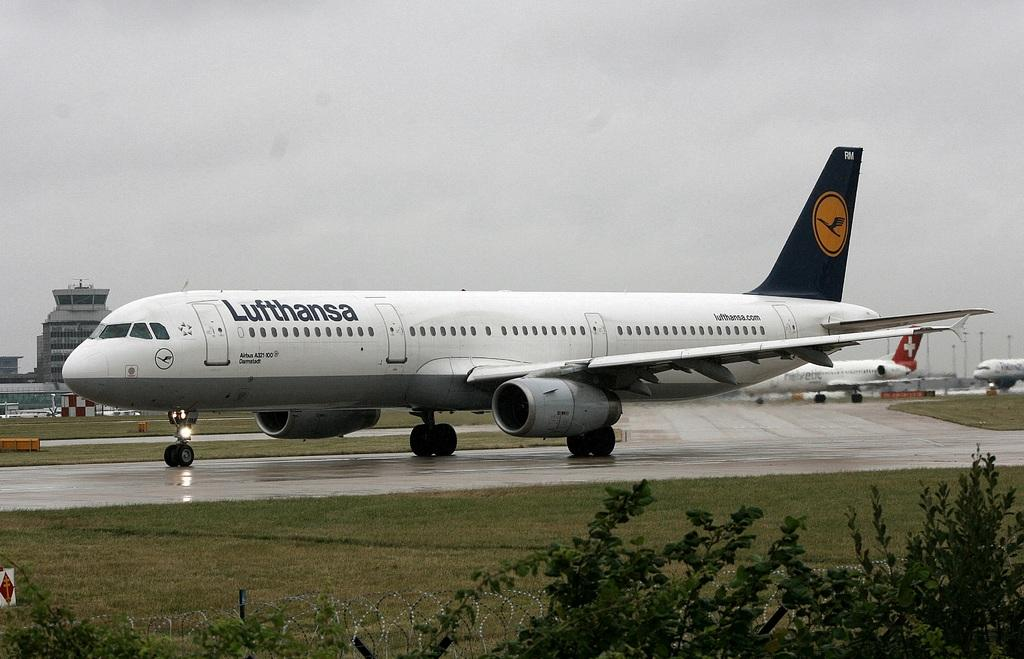What can be seen on the runway in the image? There are aeroplanes on the runway in the image. What type of barrier is present in the image? There is a fence in the image. What type of vegetation is visible in the image? There are trees in the image. What part of the ground can be seen in the image? The ground is visible in the image. What type of structures are present in the image? There are buildings in the image. What part of the natural environment is visible in the image? The sky is visible in the image, and clouds are present in the sky. Can you tell me how the aeroplanes are fighting each other in the image? There is no fighting between the aeroplanes in the image; they are simply parked on the runway. What type of comparison can be made between the trees and the buildings in the image? There is no comparison being made between the trees and the buildings in the image; they are simply two separate elements present in the scene. 